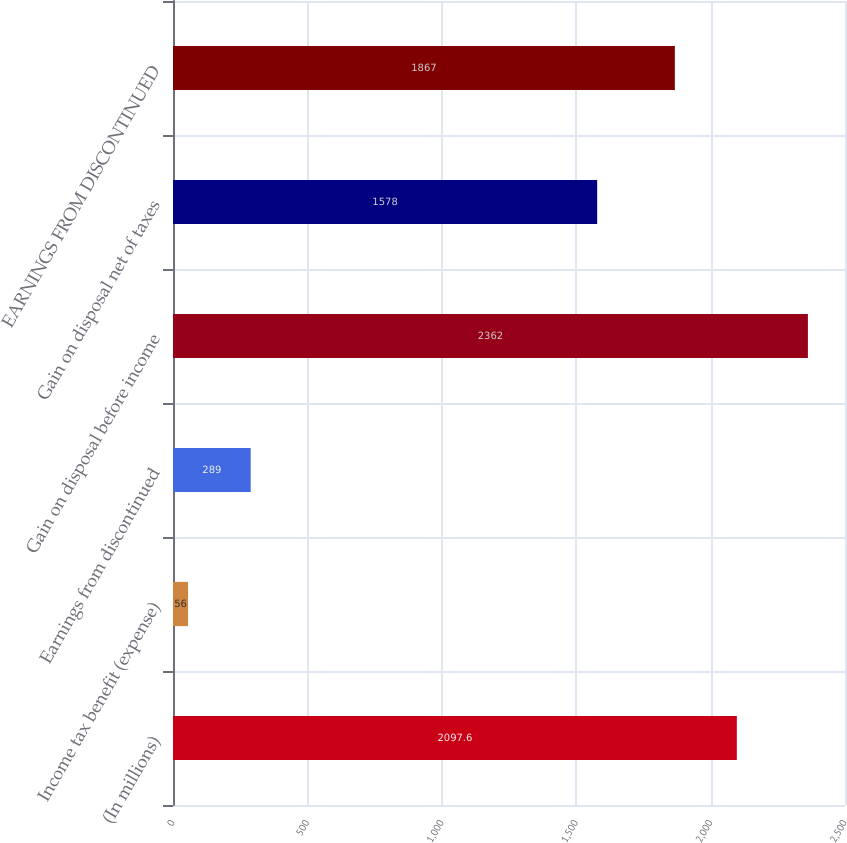<chart> <loc_0><loc_0><loc_500><loc_500><bar_chart><fcel>(In millions)<fcel>Income tax benefit (expense)<fcel>Earnings from discontinued<fcel>Gain on disposal before income<fcel>Gain on disposal net of taxes<fcel>EARNINGS FROM DISCONTINUED<nl><fcel>2097.6<fcel>56<fcel>289<fcel>2362<fcel>1578<fcel>1867<nl></chart> 